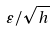<formula> <loc_0><loc_0><loc_500><loc_500>\varepsilon / { \sqrt { h } }</formula> 